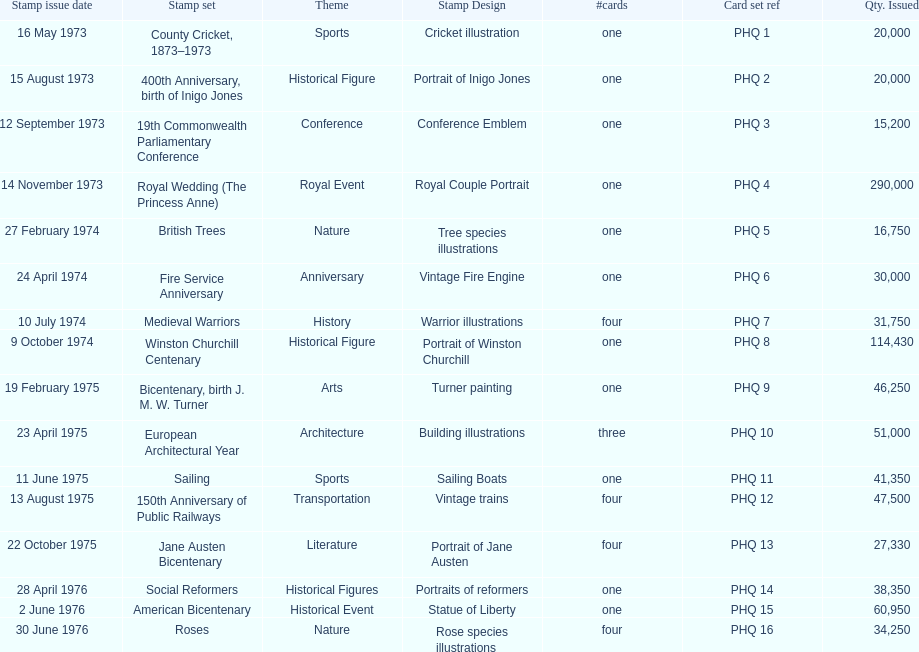Which stamp set had the greatest quantity issued? Royal Wedding (The Princess Anne). 